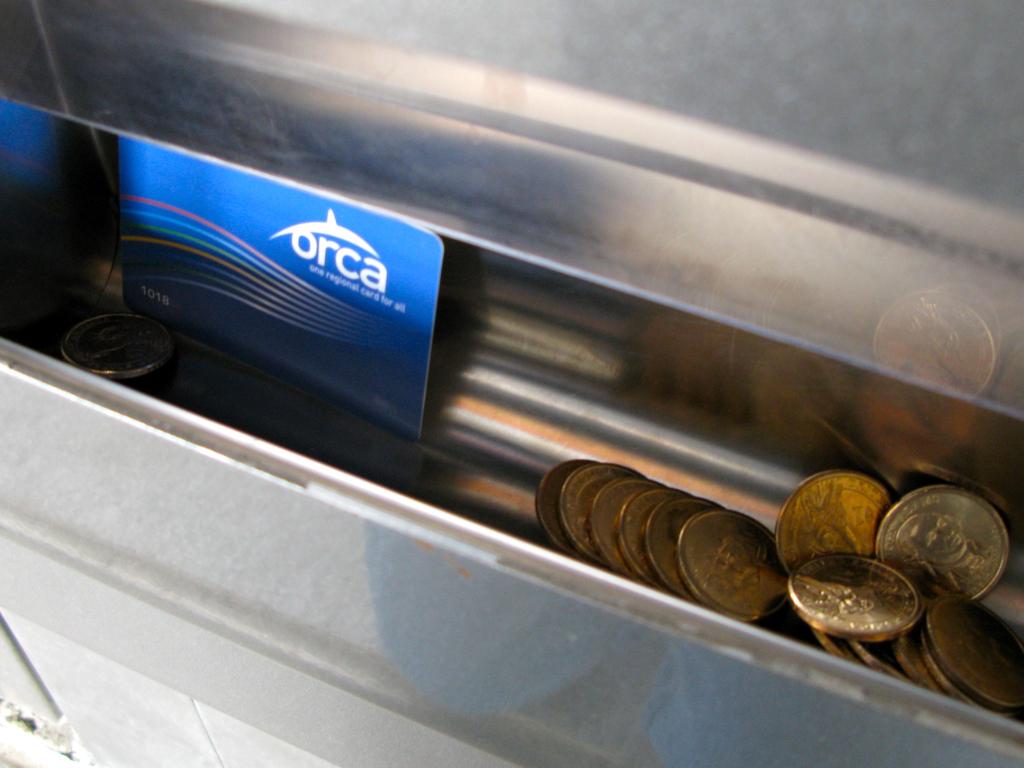What is the name of the animal on the card?
Give a very brief answer. Orca. 